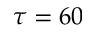<formula> <loc_0><loc_0><loc_500><loc_500>\tau = 6 0</formula> 